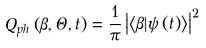<formula> <loc_0><loc_0><loc_500><loc_500>Q _ { p h } \left ( \beta , \Theta , t \right ) = \frac { 1 } { \pi } \left | \left \langle \beta | \psi \left ( t \right ) \right \rangle \right | ^ { 2 }</formula> 